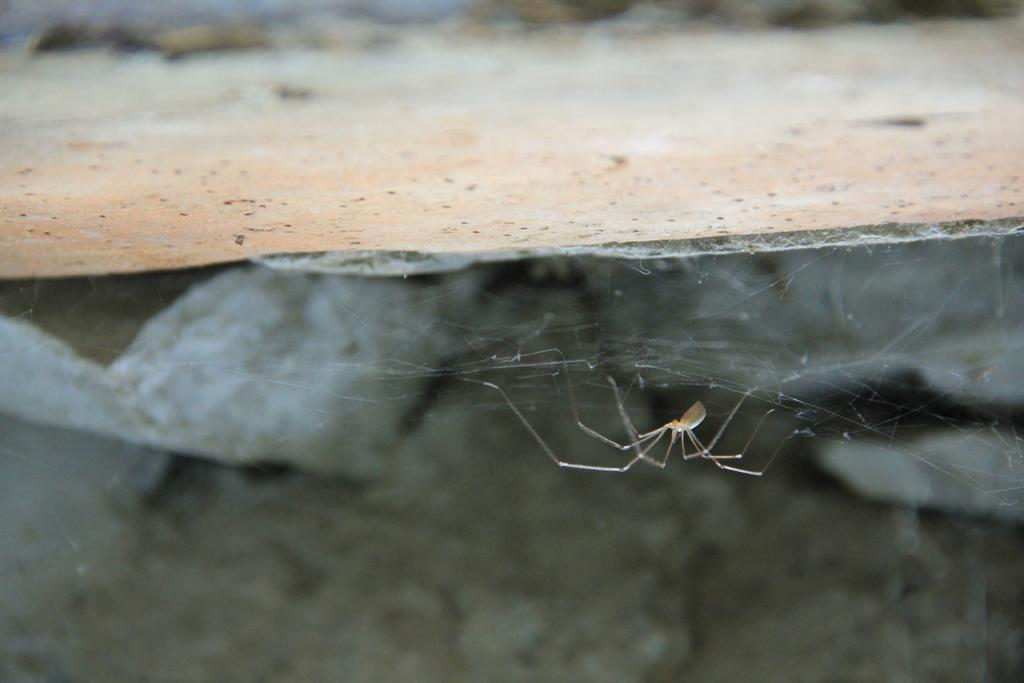What is the main object in the image? There is a slab in the image. Are there any living creatures visible in the image? Yes, there is a spider in the image. What is the spider associated with in the image? There is a web in the image, which is associated with the spider. What type of competition is the yak participating in within the image? There is no yak present in the image, so it cannot be participating in any competition. 